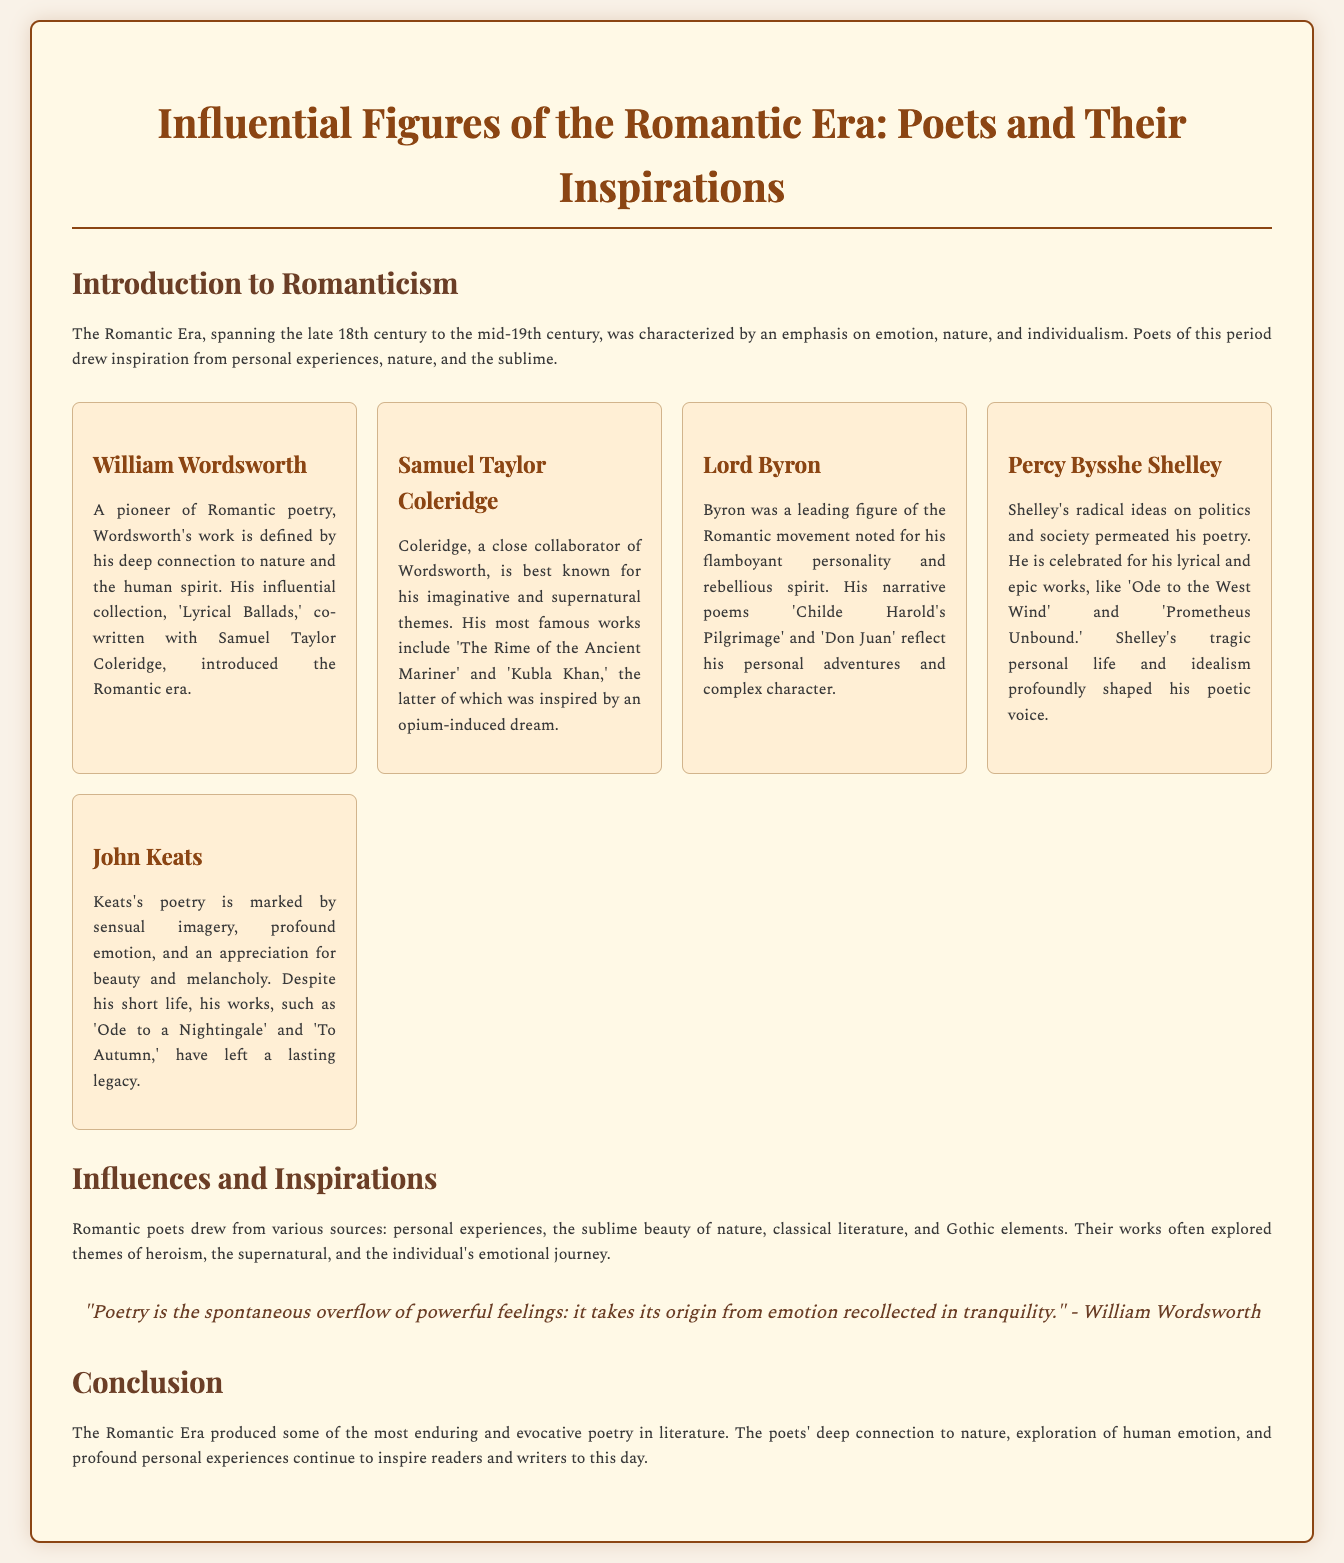what is the title of the infographic? The title of the infographic is prominently displayed at the top, which is "Influential Figures of the Romantic Era: Poets and Their Inspirations."
Answer: Influential Figures of the Romantic Era: Poets and Their Inspirations who co-wrote 'Lyrical Ballads'? The document states that 'Lyrical Ballads' was co-written by William Wordsworth and Samuel Taylor Coleridge.
Answer: William Wordsworth and Samuel Taylor Coleridge which poet is known for 'The Rime of the Ancient Mariner'? The document mentions that Samuel Taylor Coleridge is best known for his work 'The Rime of the Ancient Mariner.'
Answer: Samuel Taylor Coleridge what theme do Romantic poets often explore? The document indicates that Romantic poets often explored themes of heroism, the supernatural, and the individual's emotional journey.
Answer: Heroism, the supernatural, and the individual's emotional journey who is celebrated for his lyrical and epic works? The text notes that Percy Bysshe Shelley is celebrated for his lyrical and epic works.
Answer: Percy Bysshe Shelley what is William Wordsworth's view on poetry? The document quotes Wordsworth’s perspective that "Poetry is the spontaneous overflow of powerful feelings: it takes its origin from emotion recollected in tranquility."
Answer: Spontaneous overflow of powerful feelings how is the Romantic Era characterized? The document describes the Romantic Era as characterized by an emphasis on emotion, nature, and individualism.
Answer: Emotion, nature, and individualism which poet's works have a profound appreciation for beauty and melancholy? The document specifies that John Keats’s poetry is marked by profound appreciation for beauty and melancholy.
Answer: John Keats 